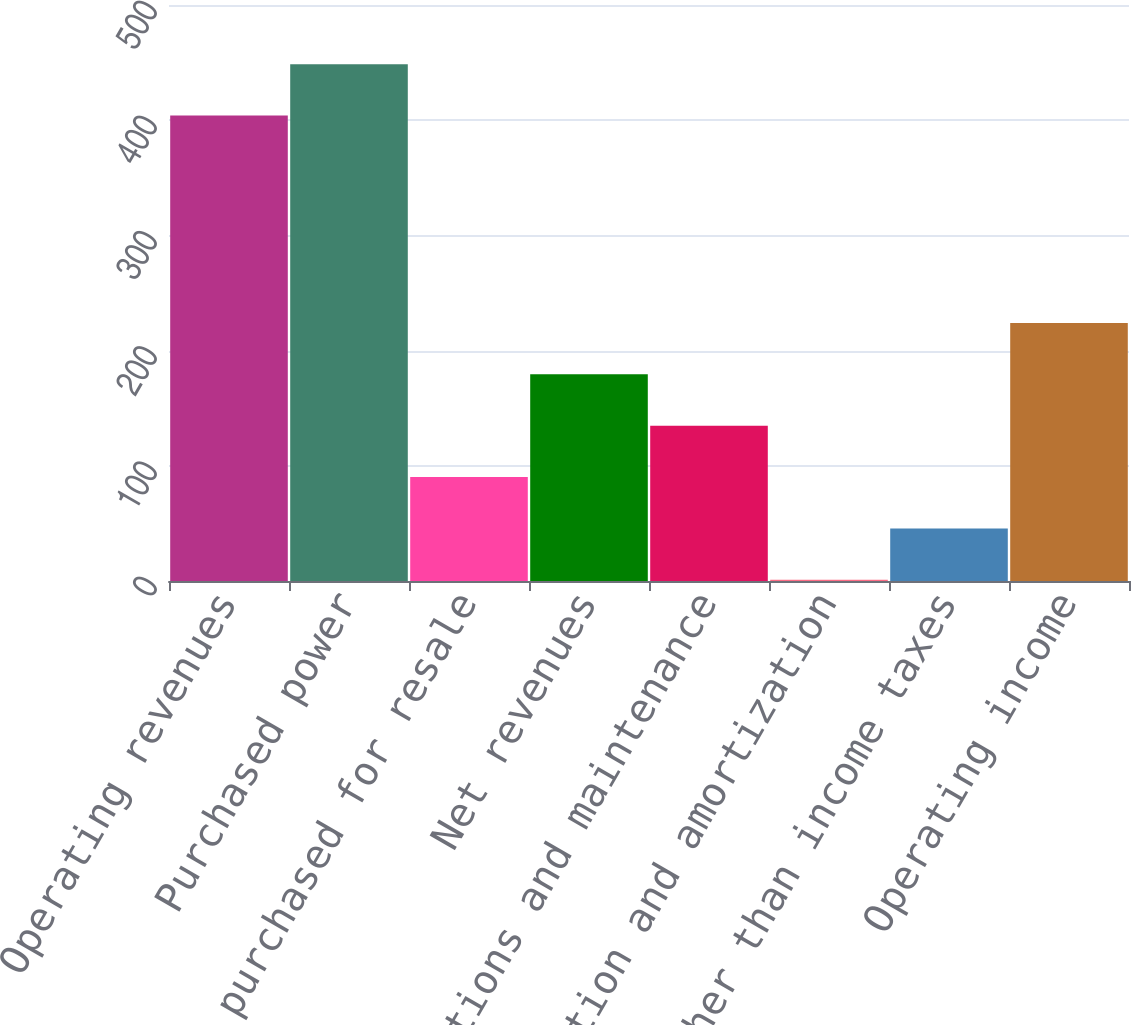<chart> <loc_0><loc_0><loc_500><loc_500><bar_chart><fcel>Operating revenues<fcel>Purchased power<fcel>Gas purchased for resale<fcel>Net revenues<fcel>Operations and maintenance<fcel>Depreciation and amortization<fcel>Taxes other than income taxes<fcel>Operating income<nl><fcel>404<fcel>448.6<fcel>90.2<fcel>179.4<fcel>134.8<fcel>1<fcel>45.6<fcel>224<nl></chart> 